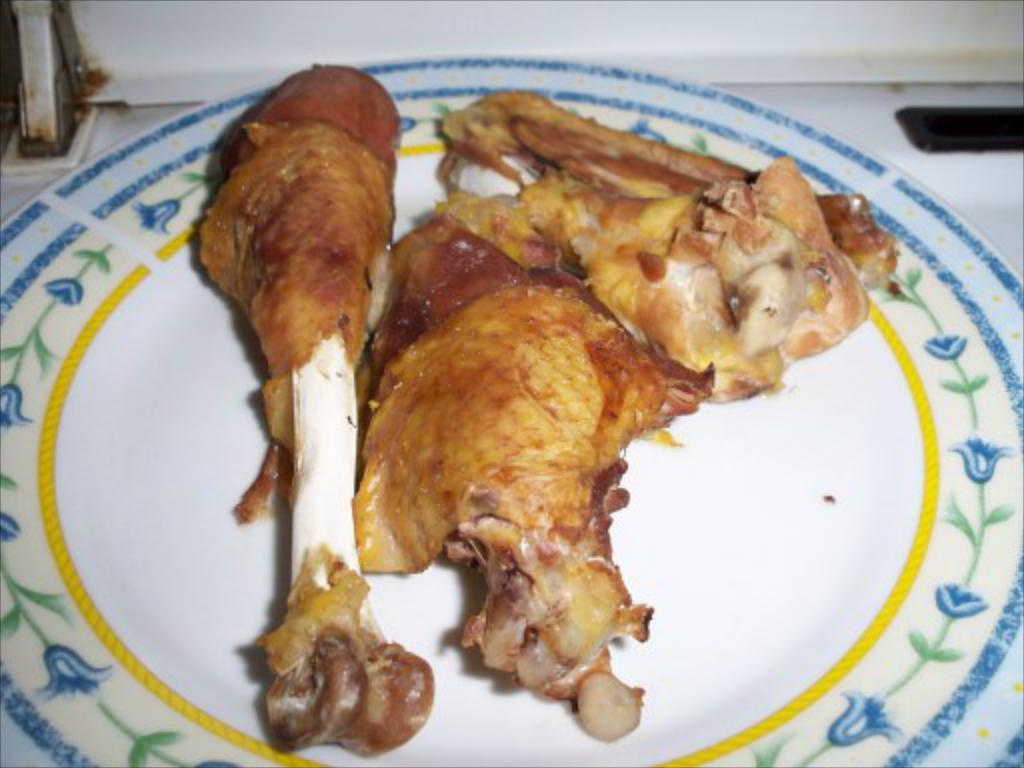What is on the plate that is visible in the image? There is a plate with food items in the image. What type of powder is sprinkled on the apparel in the image? There is no powder or apparel present in the image; it only features a plate with food items. 